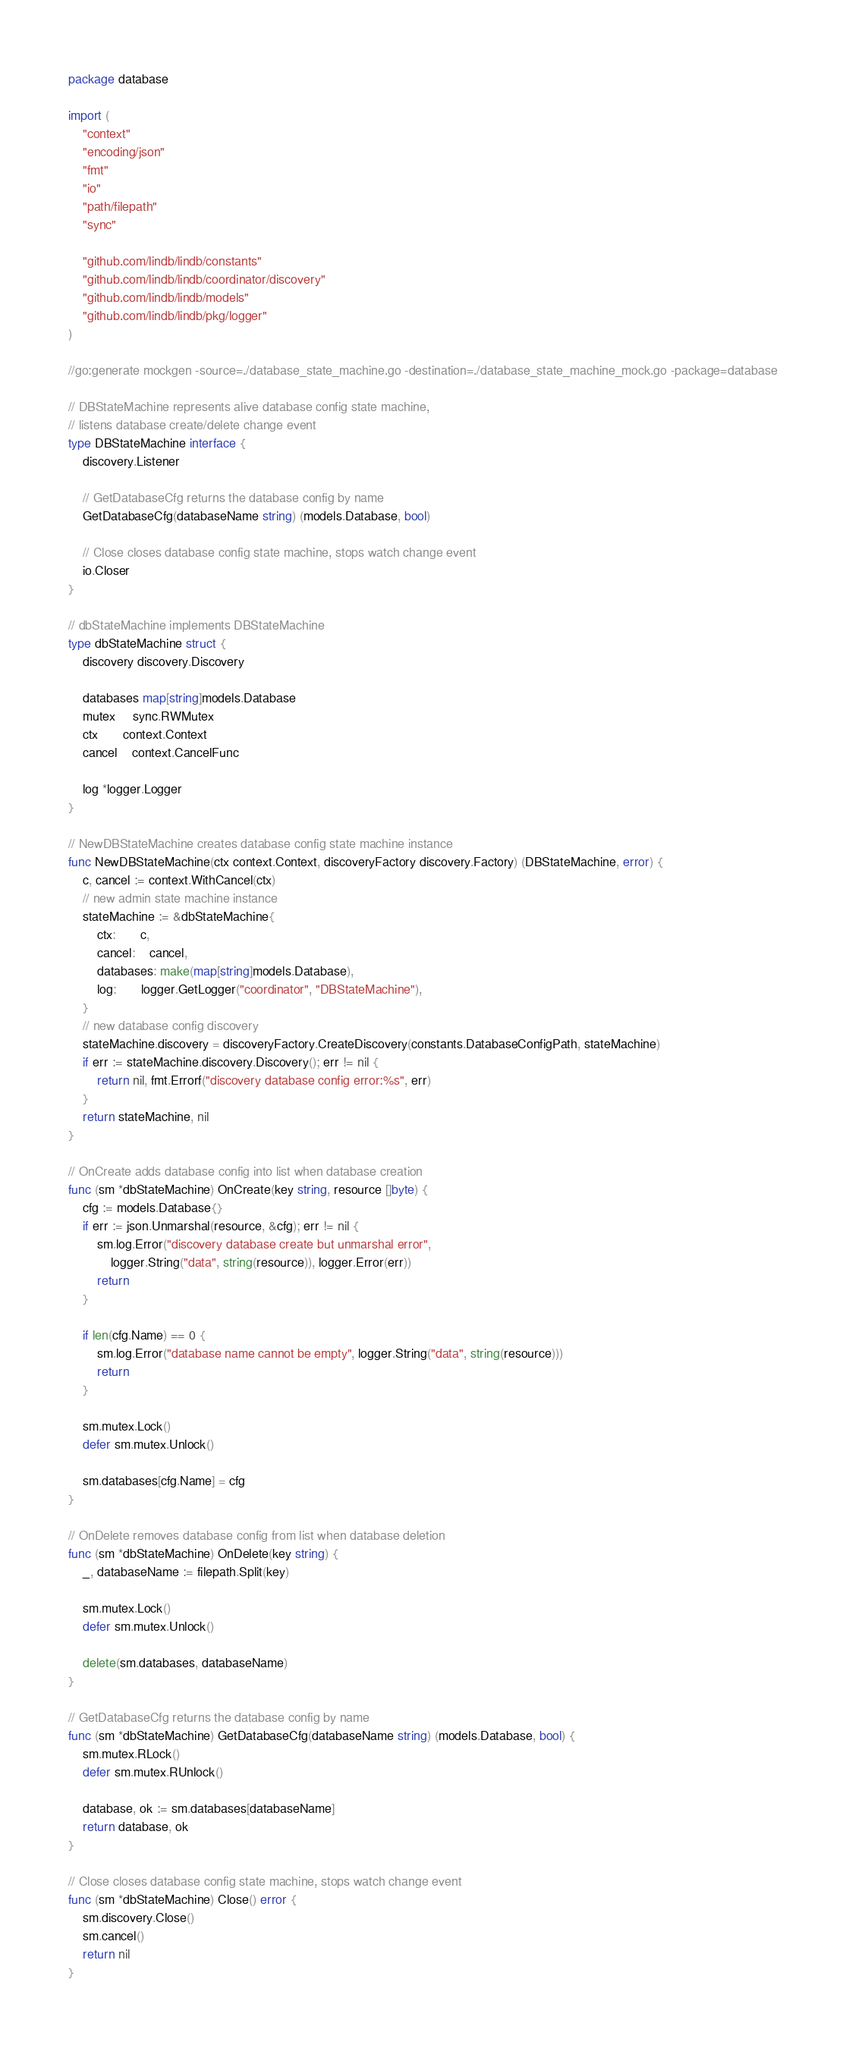<code> <loc_0><loc_0><loc_500><loc_500><_Go_>package database

import (
	"context"
	"encoding/json"
	"fmt"
	"io"
	"path/filepath"
	"sync"

	"github.com/lindb/lindb/constants"
	"github.com/lindb/lindb/coordinator/discovery"
	"github.com/lindb/lindb/models"
	"github.com/lindb/lindb/pkg/logger"
)

//go:generate mockgen -source=./database_state_machine.go -destination=./database_state_machine_mock.go -package=database

// DBStateMachine represents alive database config state machine,
// listens database create/delete change event
type DBStateMachine interface {
	discovery.Listener

	// GetDatabaseCfg returns the database config by name
	GetDatabaseCfg(databaseName string) (models.Database, bool)

	// Close closes database config state machine, stops watch change event
	io.Closer
}

// dbStateMachine implements DBStateMachine
type dbStateMachine struct {
	discovery discovery.Discovery

	databases map[string]models.Database
	mutex     sync.RWMutex
	ctx       context.Context
	cancel    context.CancelFunc

	log *logger.Logger
}

// NewDBStateMachine creates database config state machine instance
func NewDBStateMachine(ctx context.Context, discoveryFactory discovery.Factory) (DBStateMachine, error) {
	c, cancel := context.WithCancel(ctx)
	// new admin state machine instance
	stateMachine := &dbStateMachine{
		ctx:       c,
		cancel:    cancel,
		databases: make(map[string]models.Database),
		log:       logger.GetLogger("coordinator", "DBStateMachine"),
	}
	// new database config discovery
	stateMachine.discovery = discoveryFactory.CreateDiscovery(constants.DatabaseConfigPath, stateMachine)
	if err := stateMachine.discovery.Discovery(); err != nil {
		return nil, fmt.Errorf("discovery database config error:%s", err)
	}
	return stateMachine, nil
}

// OnCreate adds database config into list when database creation
func (sm *dbStateMachine) OnCreate(key string, resource []byte) {
	cfg := models.Database{}
	if err := json.Unmarshal(resource, &cfg); err != nil {
		sm.log.Error("discovery database create but unmarshal error",
			logger.String("data", string(resource)), logger.Error(err))
		return
	}

	if len(cfg.Name) == 0 {
		sm.log.Error("database name cannot be empty", logger.String("data", string(resource)))
		return
	}

	sm.mutex.Lock()
	defer sm.mutex.Unlock()

	sm.databases[cfg.Name] = cfg
}

// OnDelete removes database config from list when database deletion
func (sm *dbStateMachine) OnDelete(key string) {
	_, databaseName := filepath.Split(key)

	sm.mutex.Lock()
	defer sm.mutex.Unlock()

	delete(sm.databases, databaseName)
}

// GetDatabaseCfg returns the database config by name
func (sm *dbStateMachine) GetDatabaseCfg(databaseName string) (models.Database, bool) {
	sm.mutex.RLock()
	defer sm.mutex.RUnlock()

	database, ok := sm.databases[databaseName]
	return database, ok
}

// Close closes database config state machine, stops watch change event
func (sm *dbStateMachine) Close() error {
	sm.discovery.Close()
	sm.cancel()
	return nil
}
</code> 